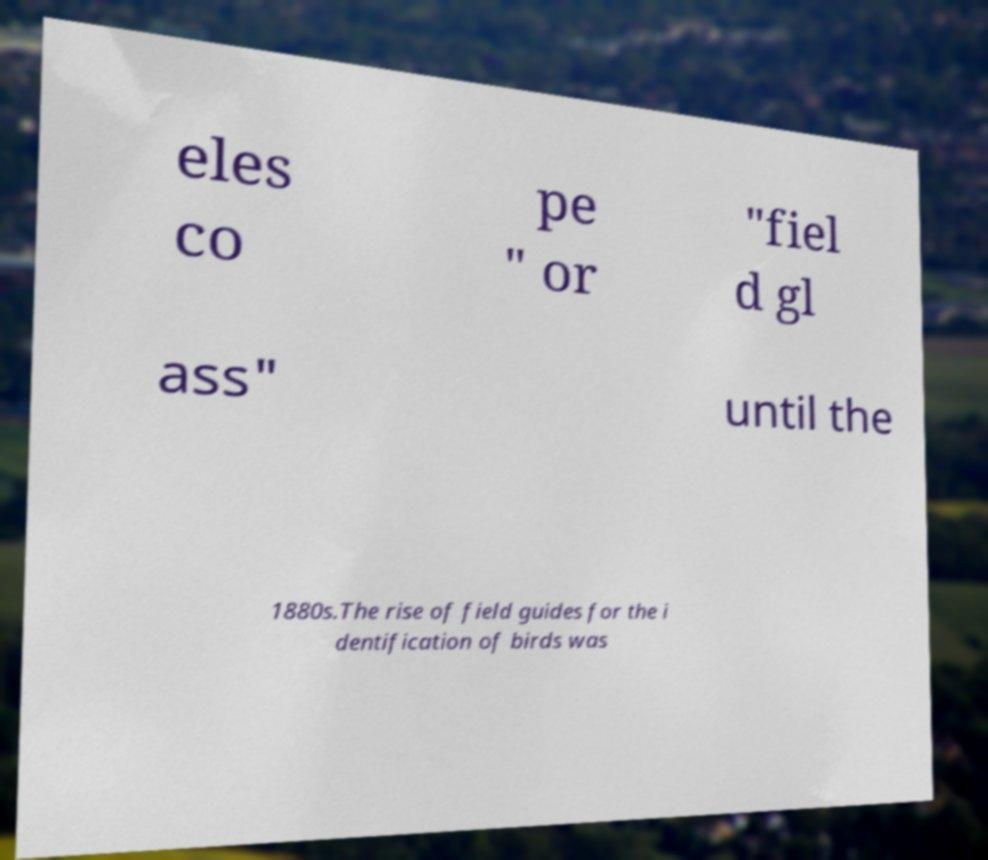Please identify and transcribe the text found in this image. eles co pe " or "fiel d gl ass" until the 1880s.The rise of field guides for the i dentification of birds was 